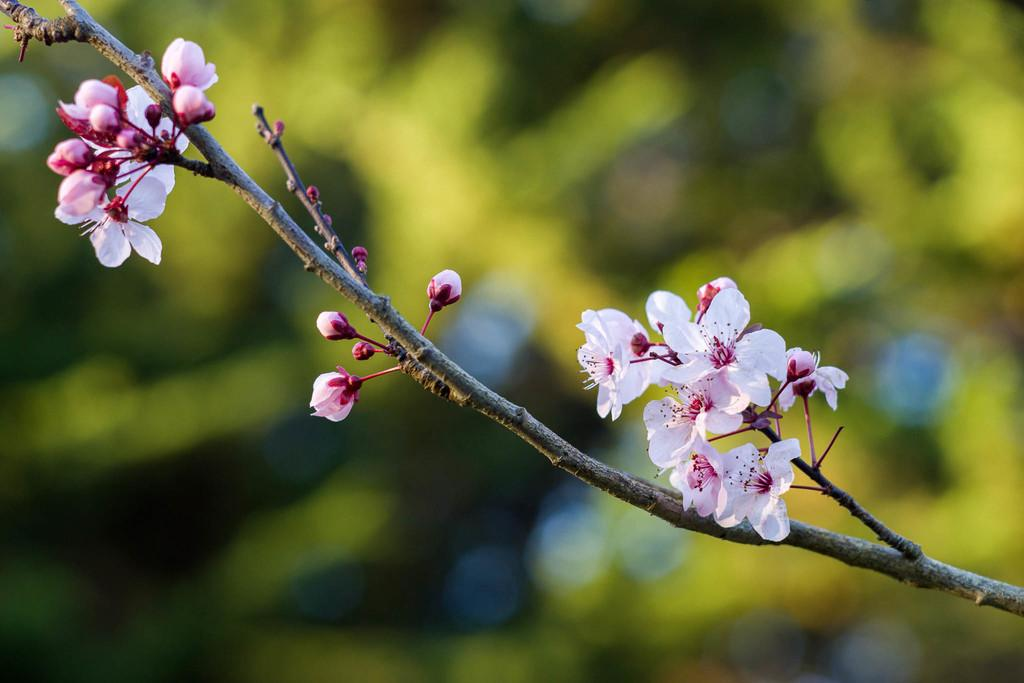What type of plant is visible in the image? There are flowers on a stem in the image. Can you describe the background of the image? The background of the image is blurred. How many trousers are hanging on the flowers in the image? There are no trousers present in the image; it features flowers on a stem. What number is written on the petals of the flowers? There is no number written on the petals of the flowers in the image. 